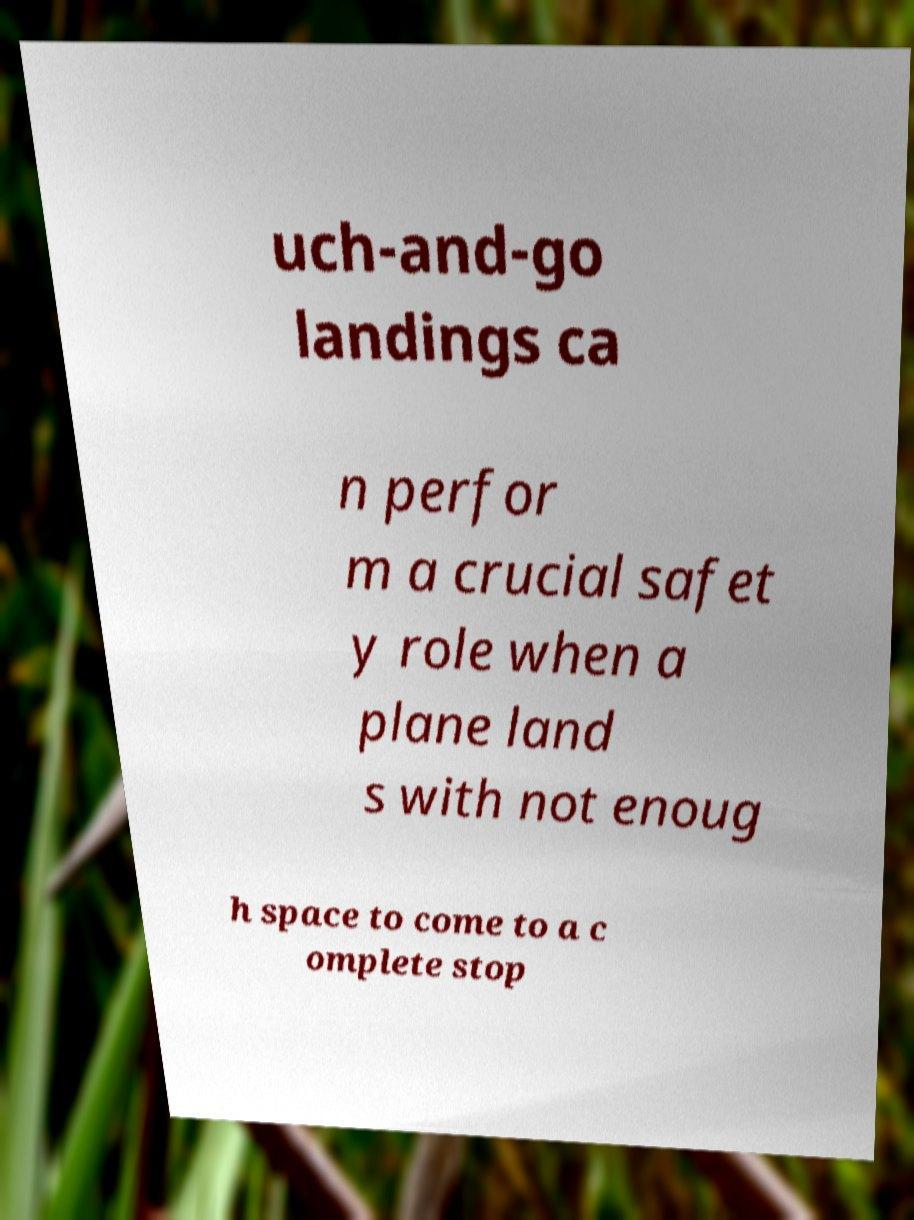For documentation purposes, I need the text within this image transcribed. Could you provide that? uch-and-go landings ca n perfor m a crucial safet y role when a plane land s with not enoug h space to come to a c omplete stop 